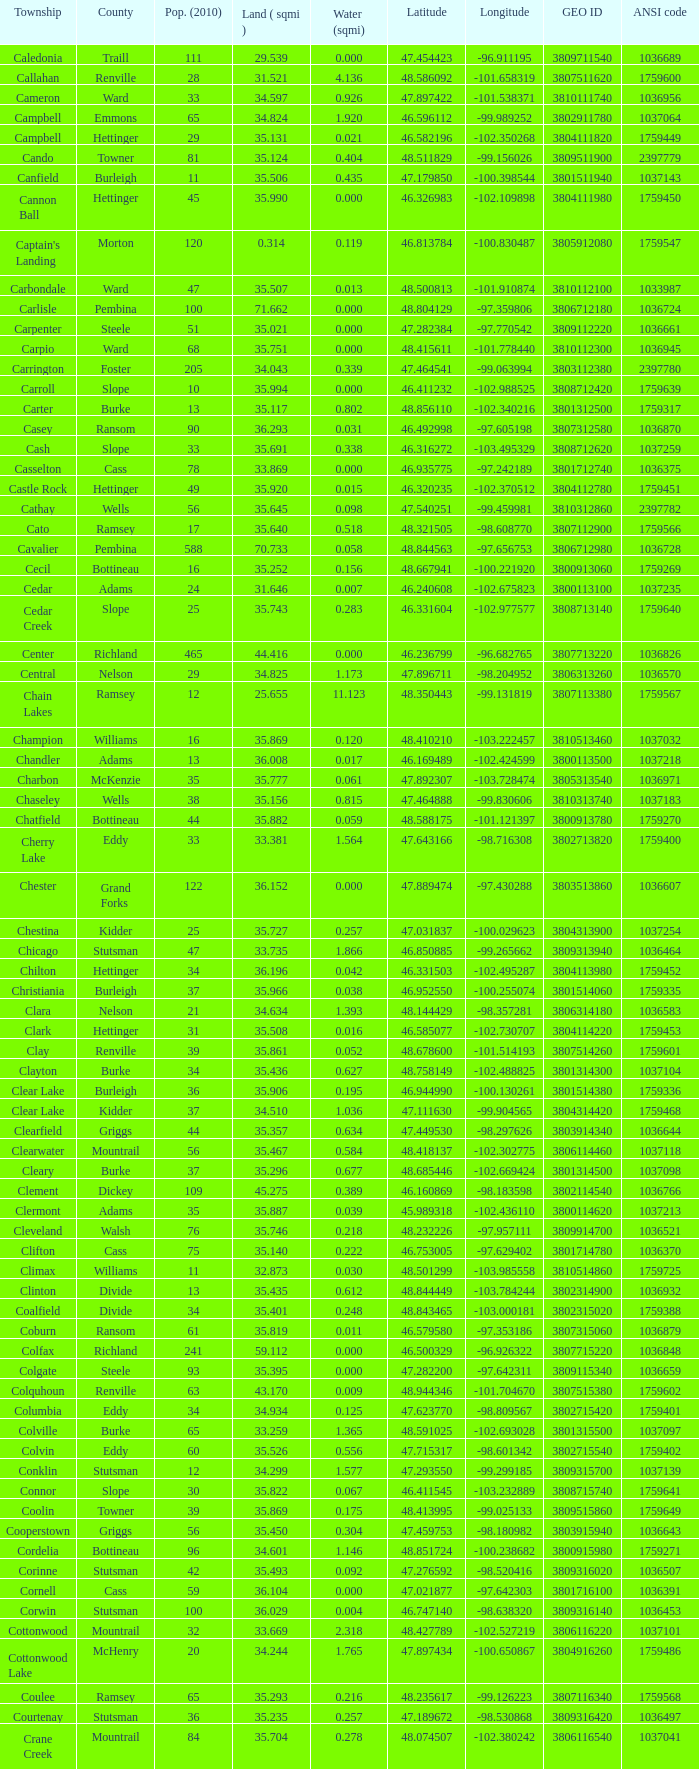What was the township with a geo ID of 3807116660? Creel. 